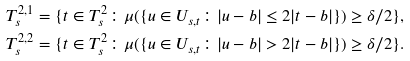<formula> <loc_0><loc_0><loc_500><loc_500>T ^ { 2 , 1 } _ { s } = \{ t \in T ^ { 2 } _ { s } \colon \mu ( \{ u \in U _ { s , t } \colon | u - b | \leq 2 | t - b | \} ) \geq \delta / 2 \} , \\ T ^ { 2 , 2 } _ { s } = \{ t \in T ^ { 2 } _ { s } \colon \mu ( \{ u \in U _ { s , t } \colon | u - b | > 2 | t - b | \} ) \geq \delta / 2 \} .</formula> 